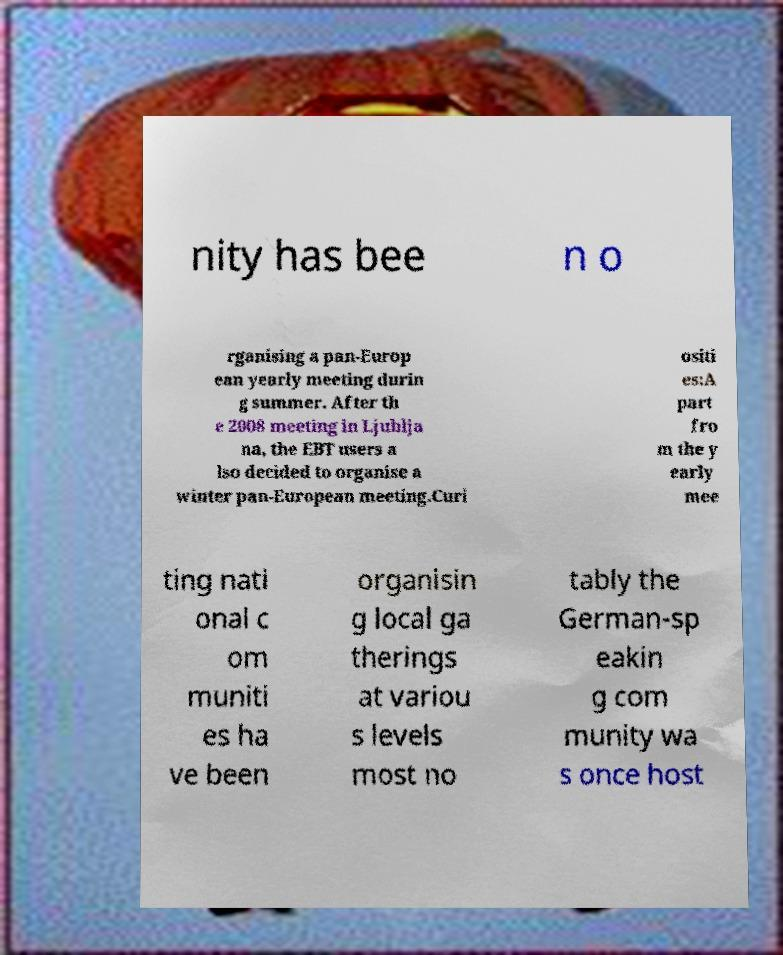I need the written content from this picture converted into text. Can you do that? nity has bee n o rganising a pan-Europ ean yearly meeting durin g summer. After th e 2008 meeting in Ljublja na, the EBT users a lso decided to organise a winter pan-European meeting.Curi ositi es:A part fro m the y early mee ting nati onal c om muniti es ha ve been organisin g local ga therings at variou s levels most no tably the German-sp eakin g com munity wa s once host 